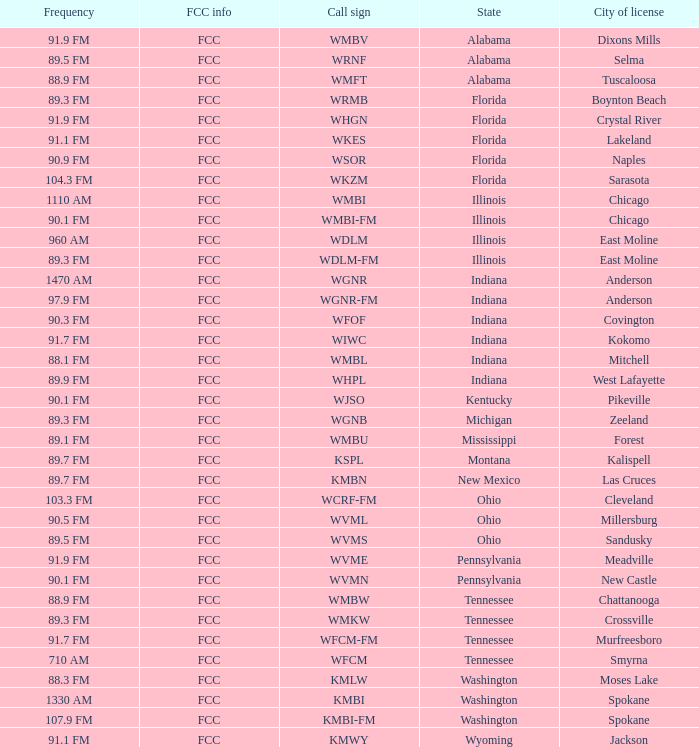What state is the radio station in that has a frequency of 90.1 FM and a city license in New Castle? Pennsylvania. 